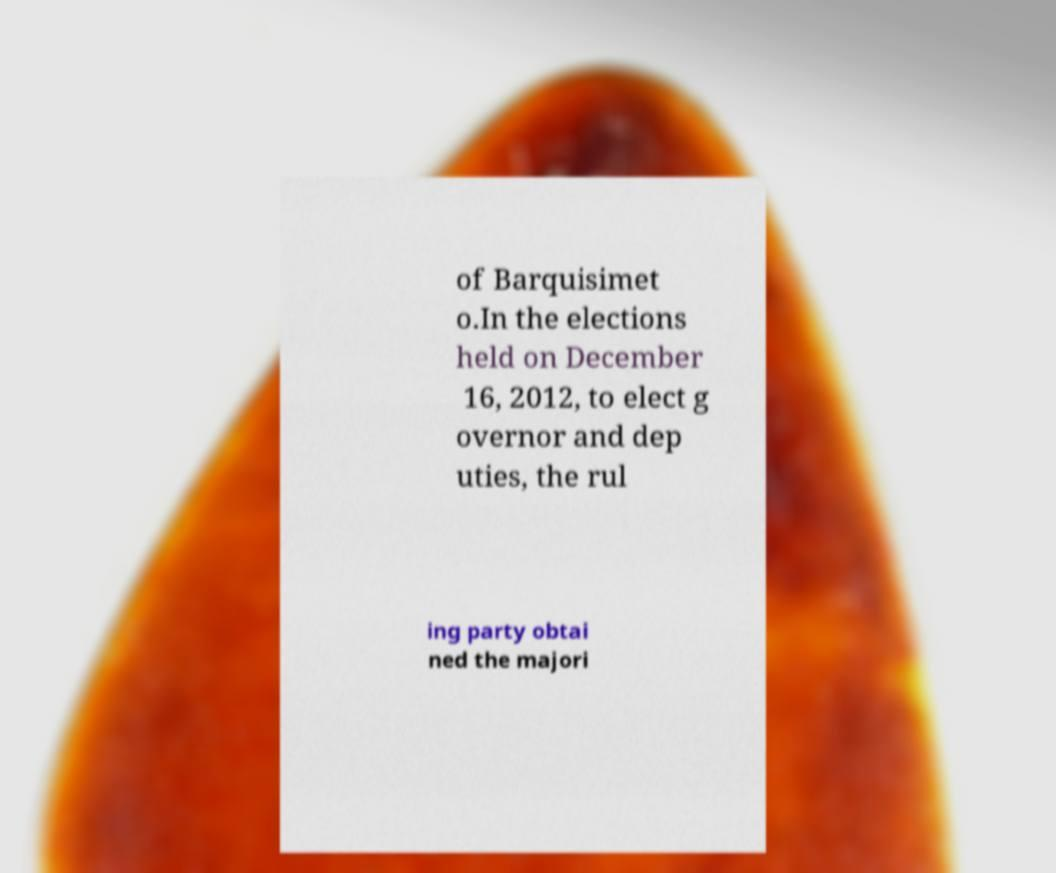What messages or text are displayed in this image? I need them in a readable, typed format. of Barquisimet o.In the elections held on December 16, 2012, to elect g overnor and dep uties, the rul ing party obtai ned the majori 